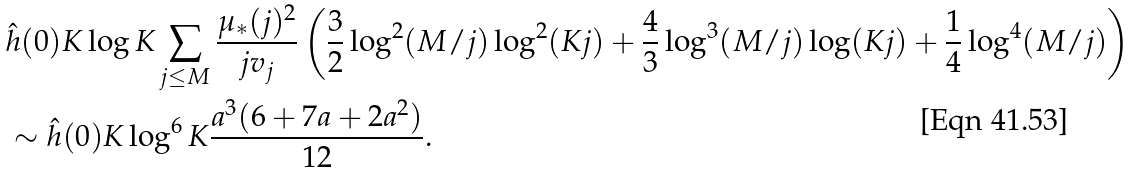Convert formula to latex. <formula><loc_0><loc_0><loc_500><loc_500>& \hat { h } ( 0 ) K \log K \sum _ { j \leq M } \frac { \mu _ { * } ( j ) ^ { 2 } } { j v _ { j } } \left ( \frac { 3 } { 2 } \log ^ { 2 } ( M / j ) \log ^ { 2 } ( K j ) + \frac { 4 } { 3 } \log ^ { 3 } ( M / j ) \log ( K j ) + \frac { 1 } { 4 } \log ^ { 4 } ( M / j ) \right ) \\ & \sim \hat { h } ( 0 ) K \log ^ { 6 } K \frac { a ^ { 3 } ( 6 + 7 a + 2 a ^ { 2 } ) } { 1 2 } .</formula> 